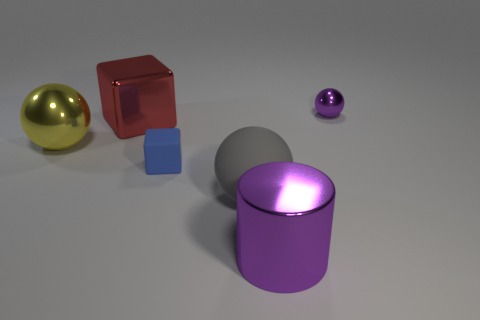Add 1 small yellow rubber objects. How many objects exist? 7 Subtract all cylinders. How many objects are left? 5 Subtract 0 brown balls. How many objects are left? 6 Subtract all tiny blue rubber blocks. Subtract all small shiny balls. How many objects are left? 4 Add 1 small blue rubber cubes. How many small blue rubber cubes are left? 2 Add 1 tiny brown metallic blocks. How many tiny brown metallic blocks exist? 1 